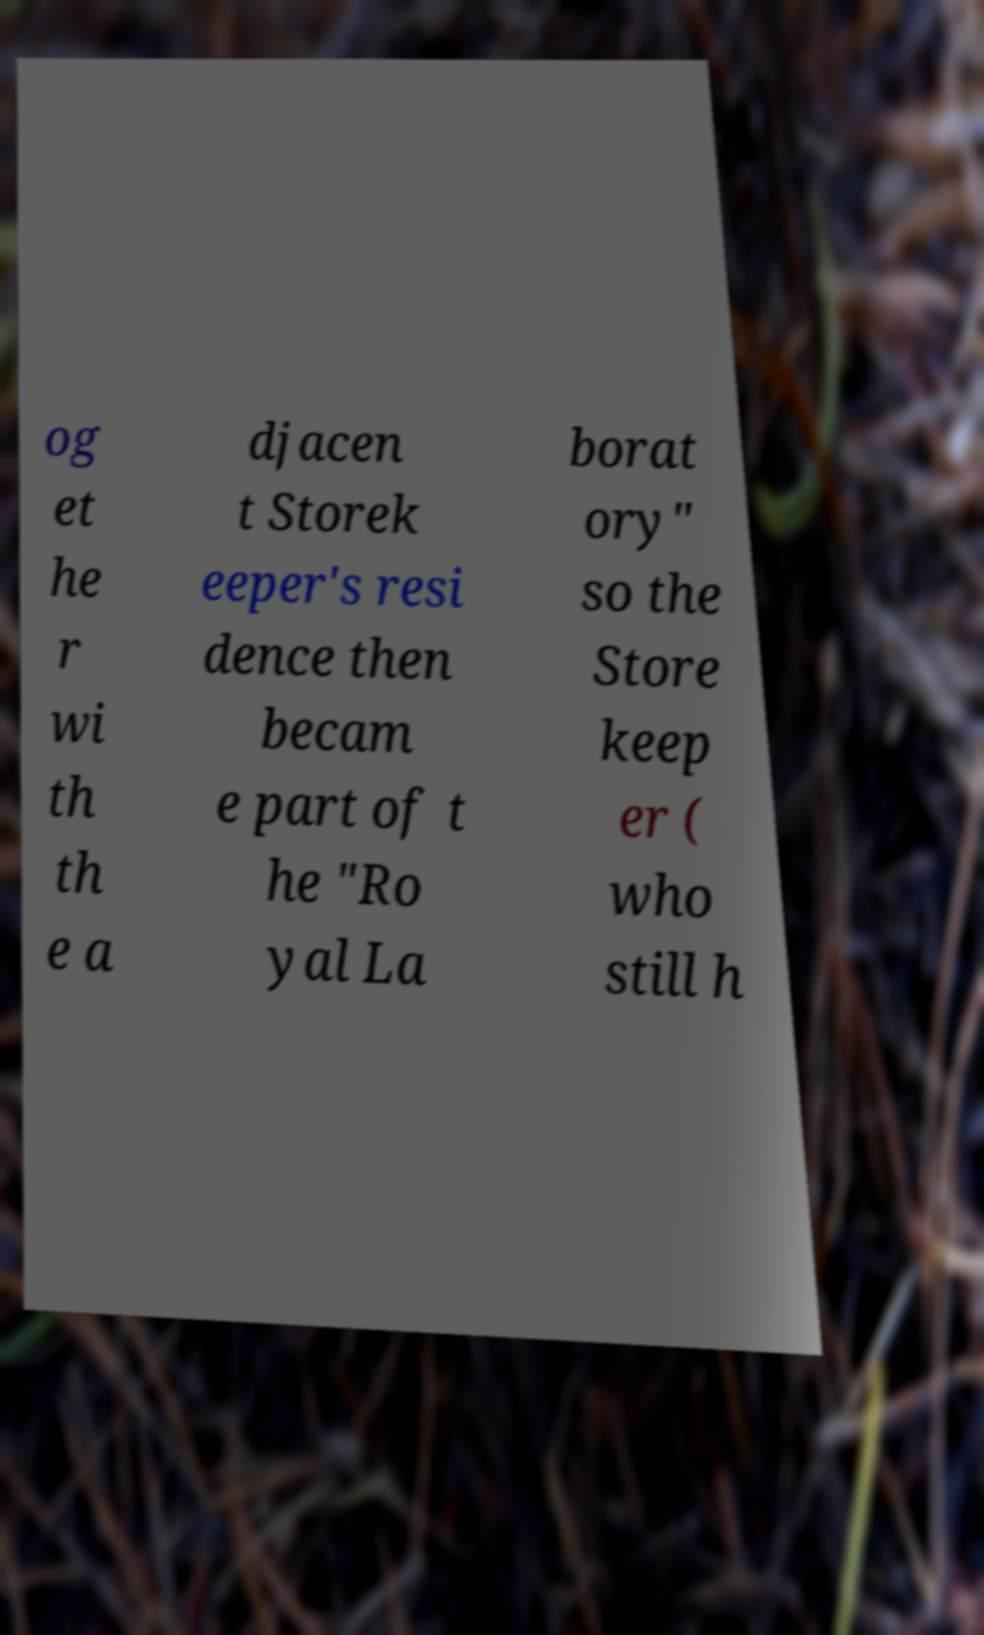Can you accurately transcribe the text from the provided image for me? og et he r wi th th e a djacen t Storek eeper's resi dence then becam e part of t he "Ro yal La borat ory" so the Store keep er ( who still h 